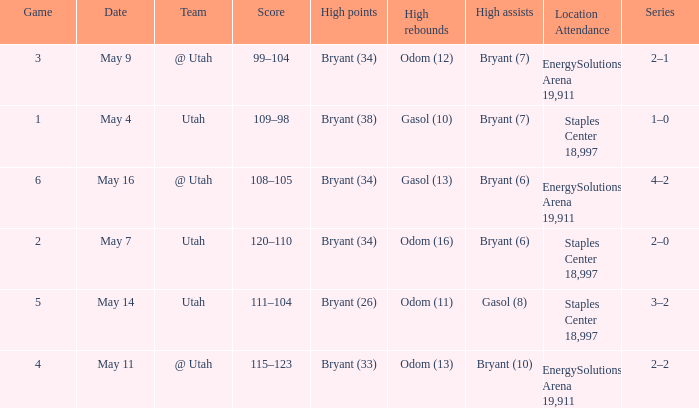What is the High rebounds with a Series with 4–2? Gasol (13). 